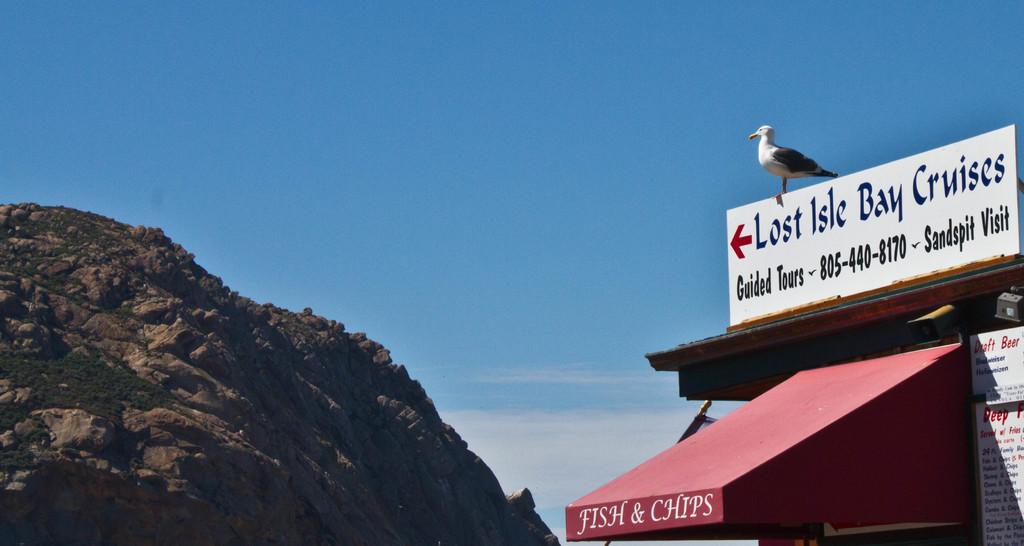What number do you call for guided tours?
Give a very brief answer. 805-440-8170. Is this the lost isle bay cruise?
Ensure brevity in your answer.  Yes. 